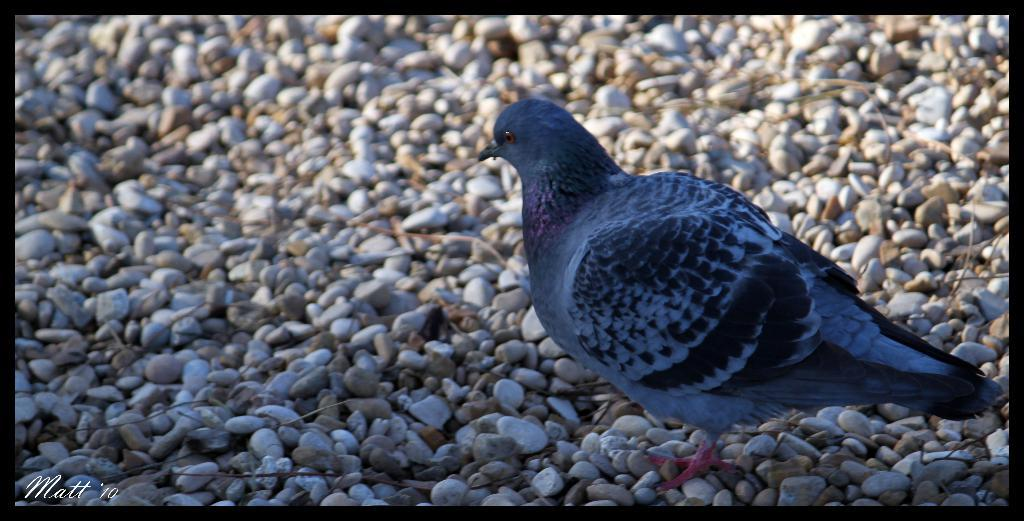What type of bird is on the ground in the image? There is a pigeon on the ground in the image. What other objects can be seen on the ground in the image? There are stones visible in the image. Can you describe any additional features of the image? There is a watermark in the image. What type of curtain can be seen hanging in the background of the image? There is no curtain present in the image; it only features a pigeon on the ground and stones. What type of notebook is the pigeon using to write in the image? There is no notebook present in the image, and the pigeon is not shown writing or interacting with any objects. 